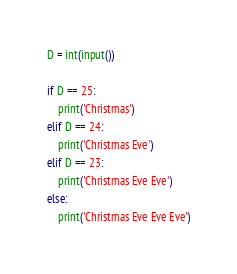<code> <loc_0><loc_0><loc_500><loc_500><_Python_>D = int(input())

if D == 25:
    print('Christmas')
elif D == 24:
    print('Christmas Eve')
elif D == 23:
    print('Christmas Eve Eve')
else:
    print('Christmas Eve Eve Eve')</code> 